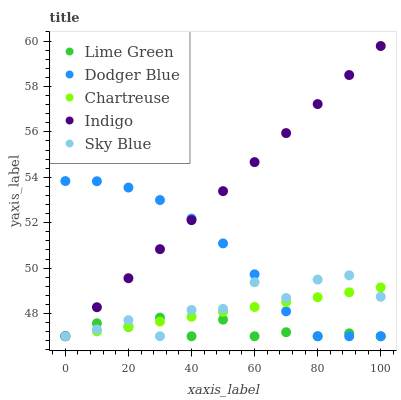Does Lime Green have the minimum area under the curve?
Answer yes or no. Yes. Does Indigo have the maximum area under the curve?
Answer yes or no. Yes. Does Chartreuse have the minimum area under the curve?
Answer yes or no. No. Does Chartreuse have the maximum area under the curve?
Answer yes or no. No. Is Chartreuse the smoothest?
Answer yes or no. Yes. Is Sky Blue the roughest?
Answer yes or no. Yes. Is Lime Green the smoothest?
Answer yes or no. No. Is Lime Green the roughest?
Answer yes or no. No. Does Dodger Blue have the lowest value?
Answer yes or no. Yes. Does Indigo have the highest value?
Answer yes or no. Yes. Does Chartreuse have the highest value?
Answer yes or no. No. Does Indigo intersect Sky Blue?
Answer yes or no. Yes. Is Indigo less than Sky Blue?
Answer yes or no. No. Is Indigo greater than Sky Blue?
Answer yes or no. No. 